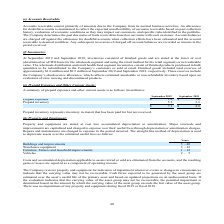According to Amcon Distributing's financial document, What does prepaid inventory refer to? inventory in-transit that has been paid for but not received.. The document states: "Prepaid inventory represents inventory in-transit that has been paid for but not received...." Also, How much is the company's respective prepaid expenses in 2018 and 2019? The document shows two values: $1.6 and $1.8 (in millions). From the document: "Prepaid expenses $ 1.8 $ 1.6 Prepaid expenses $ 1.8 $ 1.6..." Also, How much is the company's respective prepaid inventory in 2018 and 2019? The document shows two values: 3.3 and 5.3 (in millions). From the document: "Prepaid inventory 5.3 3.3 Prepaid inventory 5.3 3.3..." Also, can you calculate: What is the percentage change in the company's total prepaid expenses and other current assets between 2018 and 2019? To answer this question, I need to perform calculations using the financial data. The calculation is: (7.1 - 4.9)/4.9 , which equals 44.9 (percentage). This is based on the information: "$ 7.1 $ 4.9 $ 7.1 $ 4.9..." The key data points involved are: 7.1. Also, can you calculate: What is the percentage change in the company's prepaid expenses between 2018 and 2019? To answer this question, I need to perform calculations using the financial data. The calculation is: (1.8 - 1.6)/1.6 , which equals 12.5 (percentage). This is based on the information: "Prepaid expenses $ 1.8 $ 1.6 Prepaid expenses $ 1.8 $ 1.6..." The key data points involved are: 1.6, 1.8. Also, can you calculate: What is the value of the company's 2018 prepaid inventory as a percentage of its total prepaid expenses and other current assets? Based on the calculation: 3.3/4.9 , the result is 67.35 (percentage). This is based on the information: "Prepaid inventory 5.3 3.3 $ 7.1 $ 4.9..." The key data points involved are: 3.3, 4.9. 